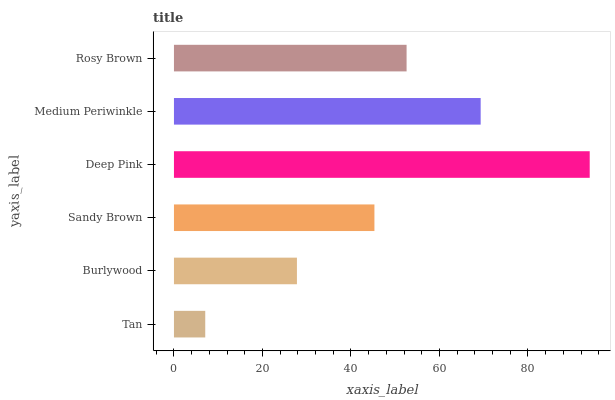Is Tan the minimum?
Answer yes or no. Yes. Is Deep Pink the maximum?
Answer yes or no. Yes. Is Burlywood the minimum?
Answer yes or no. No. Is Burlywood the maximum?
Answer yes or no. No. Is Burlywood greater than Tan?
Answer yes or no. Yes. Is Tan less than Burlywood?
Answer yes or no. Yes. Is Tan greater than Burlywood?
Answer yes or no. No. Is Burlywood less than Tan?
Answer yes or no. No. Is Rosy Brown the high median?
Answer yes or no. Yes. Is Sandy Brown the low median?
Answer yes or no. Yes. Is Deep Pink the high median?
Answer yes or no. No. Is Medium Periwinkle the low median?
Answer yes or no. No. 